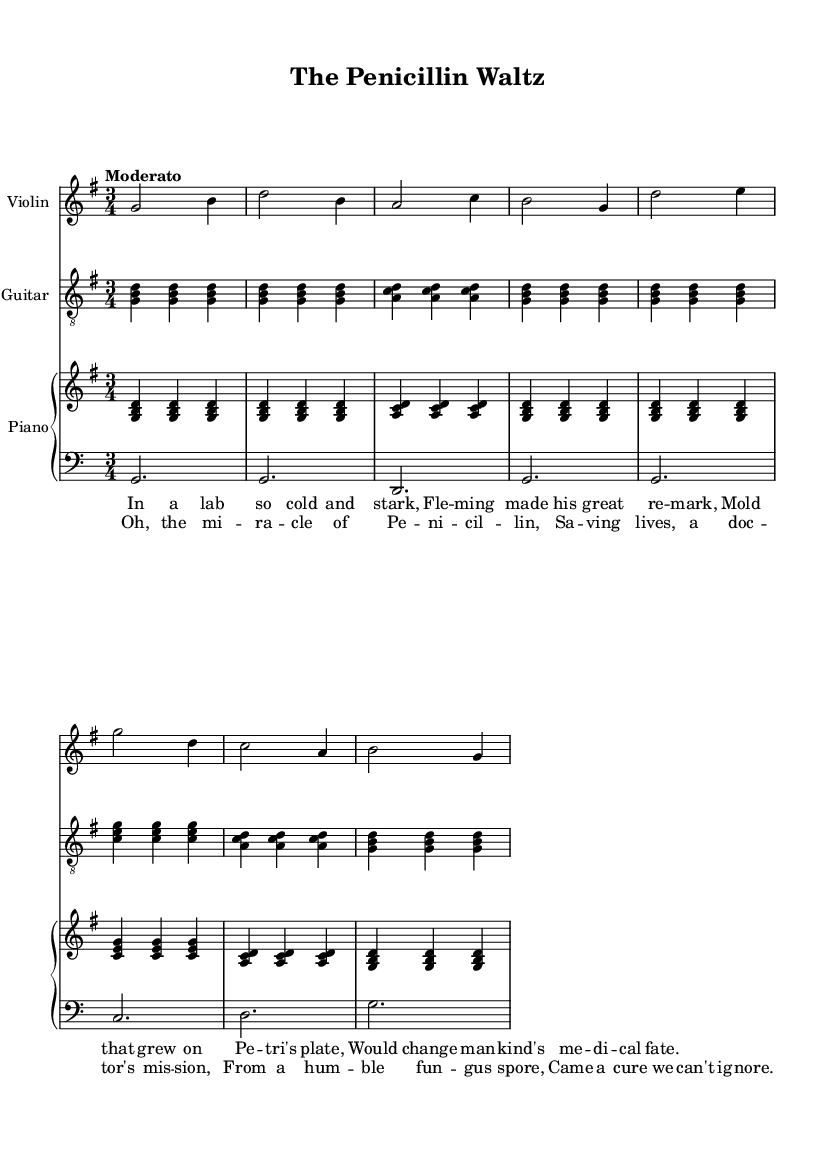What is the key signature of this music? The key signature is G major, which has one sharp (F#). This can be identified by looking at the key signature at the beginning of the staff lines, confirming it is G major.
Answer: G major What is the time signature of this music? The time signature is 3/4, indicating that there are three beats in each measure and the quarter note gets the beat. This is noted at the beginning of the sheet music, right after the key signature.
Answer: 3/4 What is the tempo marking for this piece? The tempo marking is "Moderato," which suggests a moderate speed. This marking is found at the start of the music, providing guidance on the performance tempo.
Answer: Moderato How many measures are in the chorus? The chorus consists of 4 measures. By visually counting the measures in the chorus section, each separated by a vertical line, we can determine this quantity.
Answer: 4 Which instrument plays the melody? The violin plays the melody. This is indicated by its line of music being higher in pitch, and is often recognized as the lead in many compositions, especially in folk-style arrangements.
Answer: Violin What is the primary theme of the lyrics? The primary theme of the lyrics is medical discovery, specifically regarding penicillin. This is evident from the lyrical content, which tells a story about a significant medical breakthrough.
Answer: Medical discovery What type of music structure is used in this piece? The structure follows a verse-chorus format, common in folk ballads, consisting of verses that tell a story followed by a repeated chorus that emphasizes the main theme. This is identifiable by the lyric layout and repetition of the chorus.
Answer: Verse-chorus 